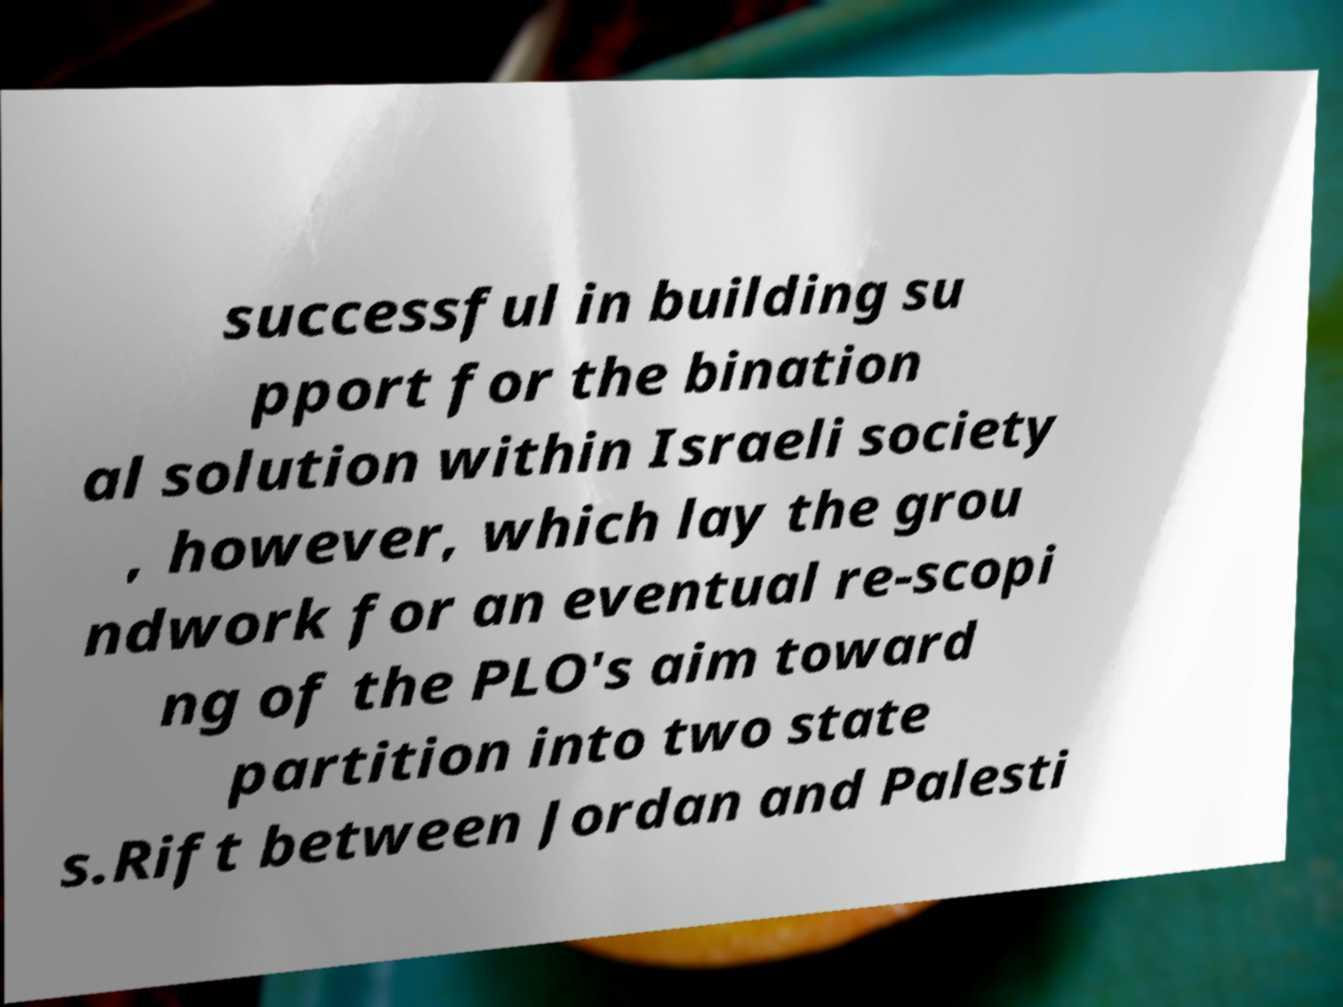Could you assist in decoding the text presented in this image and type it out clearly? successful in building su pport for the bination al solution within Israeli society , however, which lay the grou ndwork for an eventual re-scopi ng of the PLO's aim toward partition into two state s.Rift between Jordan and Palesti 